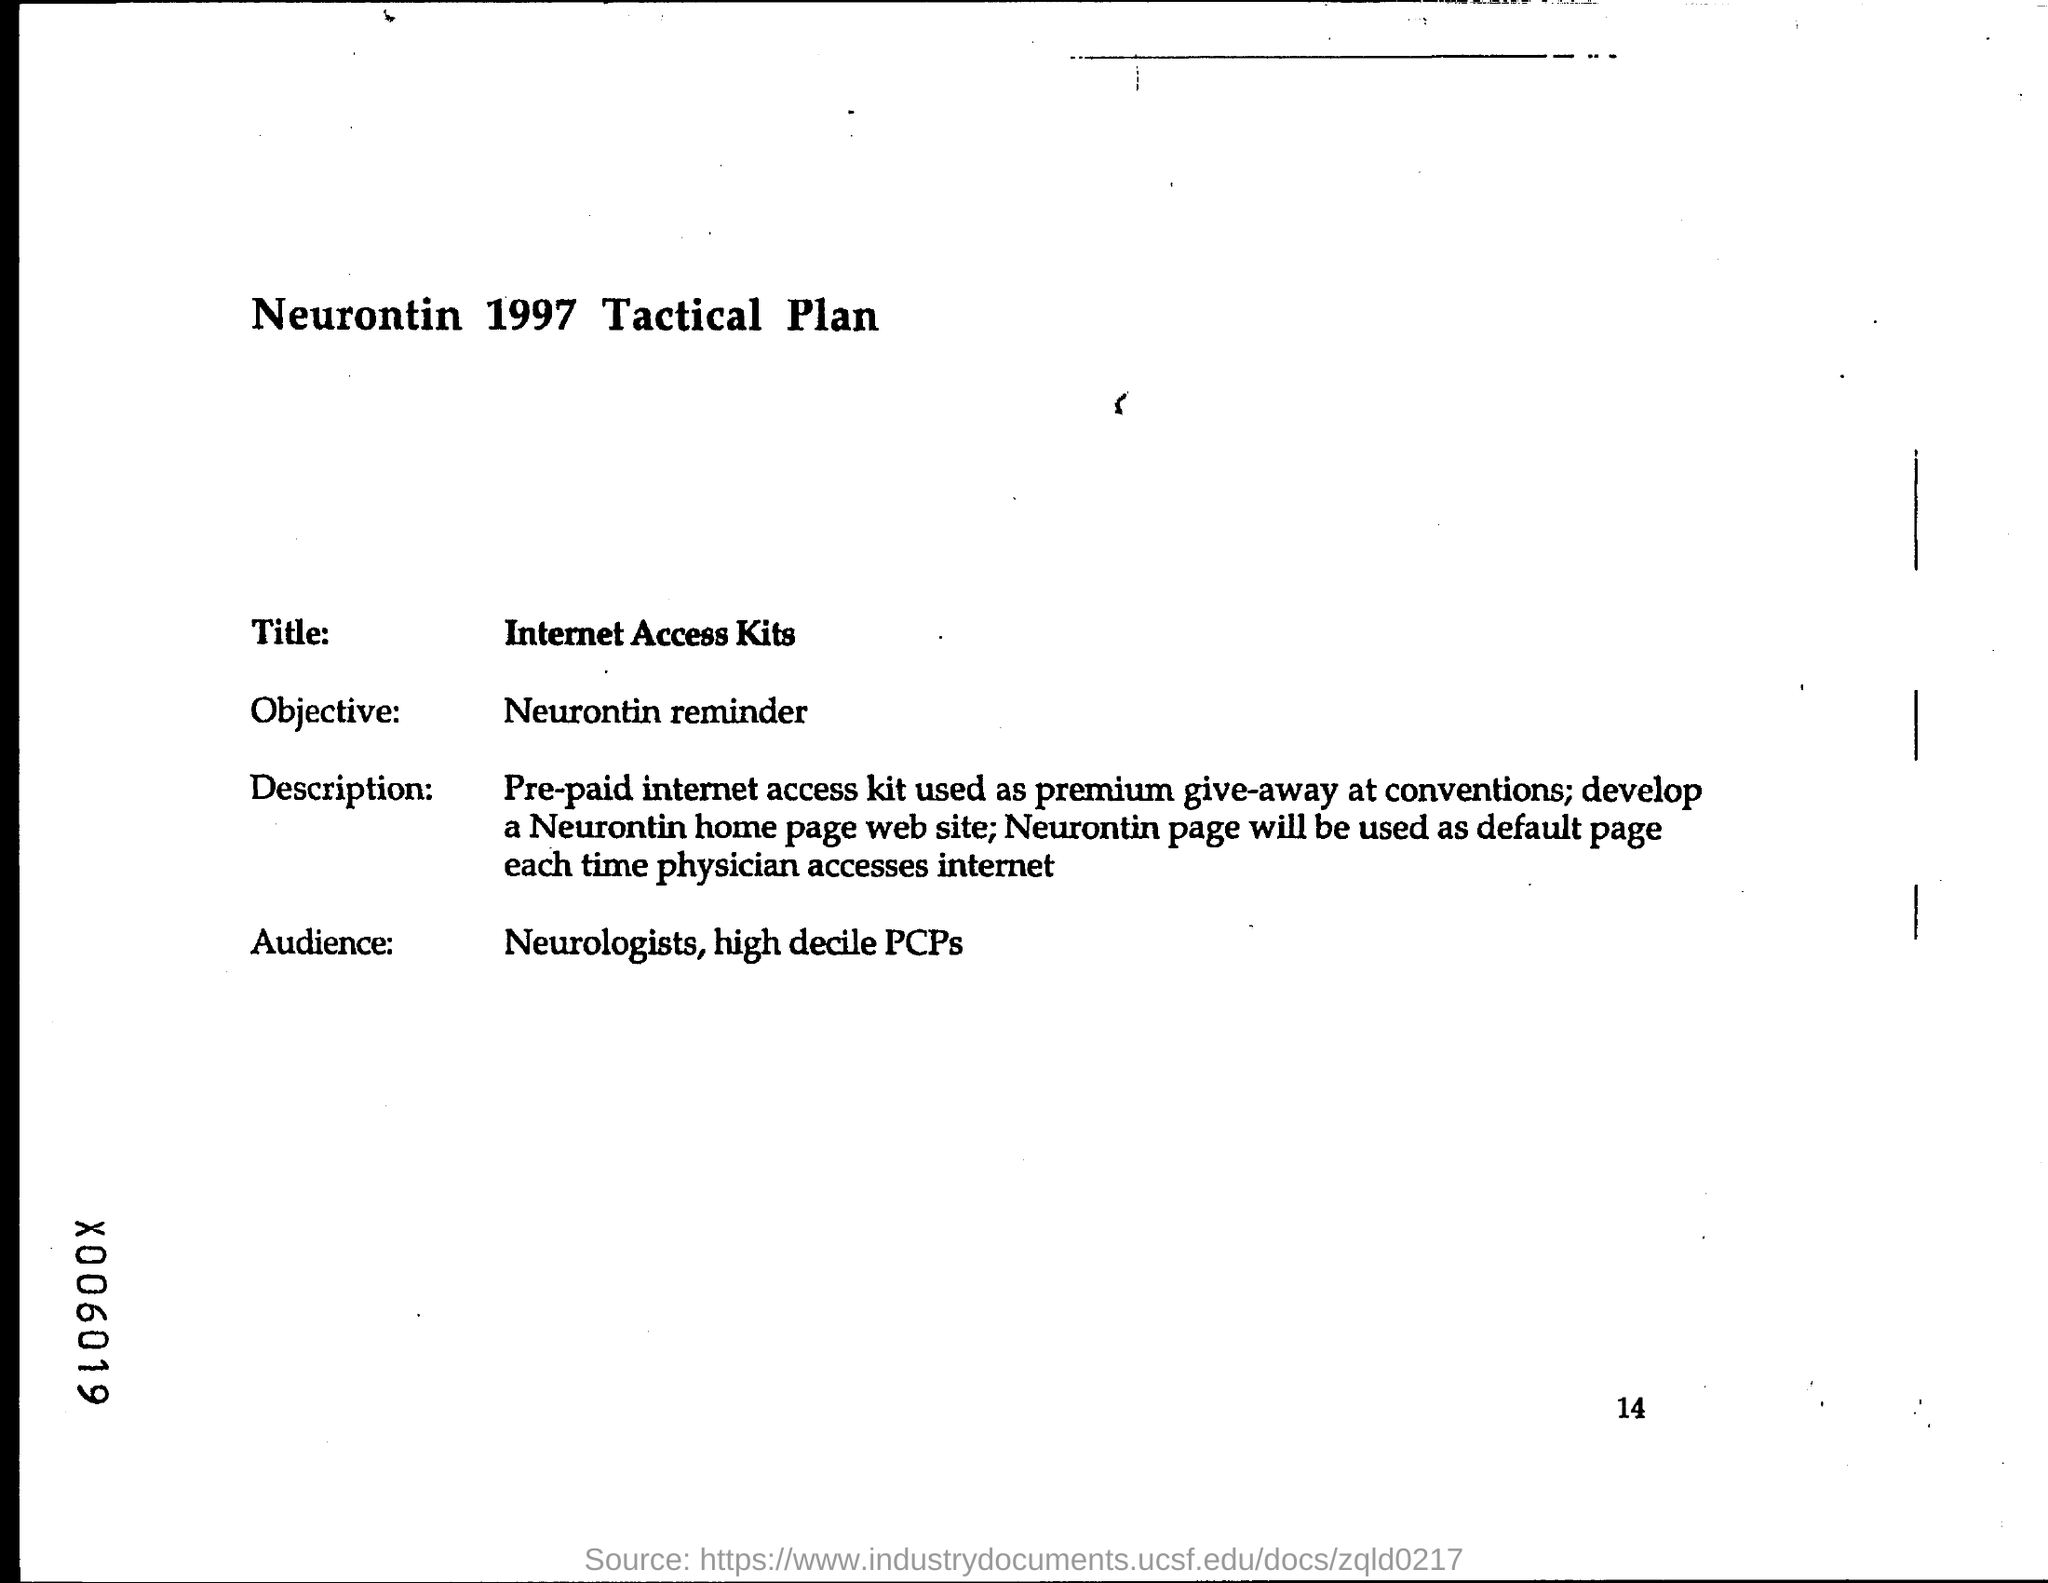Specify some key components in this picture. What is the Title?" Internet Access Kits. The objective is to remind the reader about Neurontin. The intended audience for the paper are neurologists and high-decile primary care physicians. 